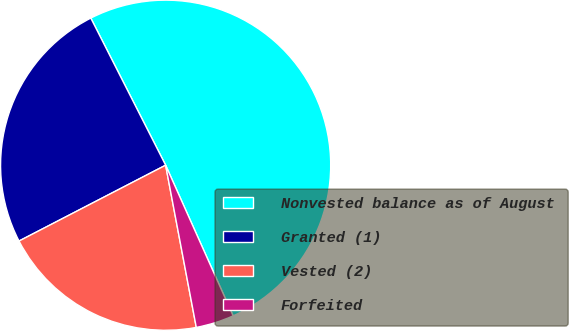Convert chart. <chart><loc_0><loc_0><loc_500><loc_500><pie_chart><fcel>Nonvested balance as of August<fcel>Granted (1)<fcel>Vested (2)<fcel>Forfeited<nl><fcel>50.79%<fcel>25.11%<fcel>20.38%<fcel>3.73%<nl></chart> 